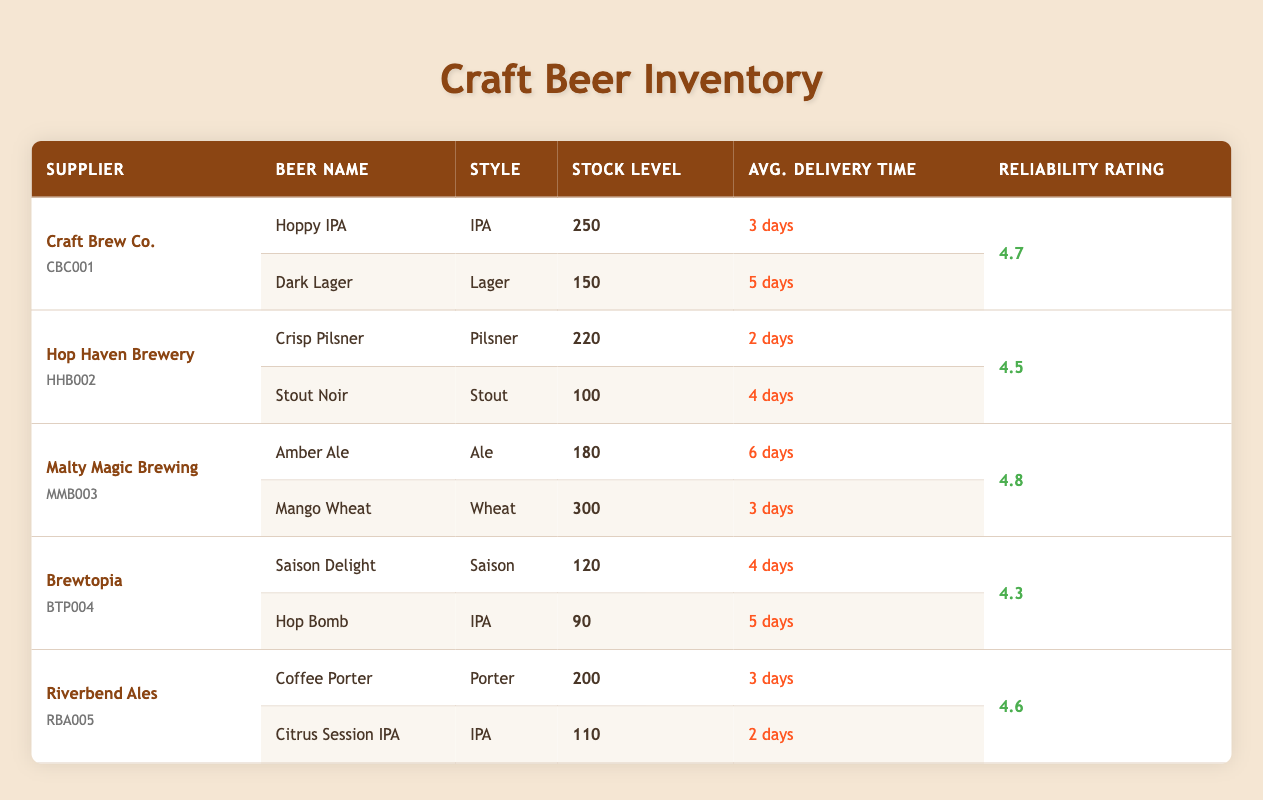What is the stock level for the Hoppy IPA? The Hoppy IPA is listed under Craft Brew Co., and its stock level is explicitly stated as 250 units in the table.
Answer: 250 Which supplier has the highest reliability rating? By checking the reliability ratings, Malty Magic Brewing has the highest rating of 4.8 compared to others, which are lower.
Answer: 4.8 What is the average delivery time for beers from Riverbend Ales? Riverbend Ales has two beers: Coffee Porter with an average delivery time of 3 days and Citrus Session IPA with 2 days. The average is (3 + 2)/2 = 2.5 days.
Answer: 2.5 days How many beers from Hop Haven Brewery exceed a delivery time of 3 days? Hop Haven Brewery's product range shows Crisp Pilsner with 2 days and Stout Noir with 4 days. Only Stout Noir exceeds 3 days, so there is 1 beer.
Answer: 1 Does Brewtopia have any beers with a stock level higher than 130? Brewtopia's Saison Delight has a stock level of 120, and Hop Bomb has a stock level of 90. Both are lower than 130, so the answer is no.
Answer: No What is the total stock level of all beers supplied by Malty Magic Brewing? Malty Magic Brewing has Amber Ale with a stock level of 180 and Mango Wheat with 300. The total stock level is 180 + 300 = 480.
Answer: 480 Which beer has the shortest average delivery time and its corresponding supplier? The shortest delivery time in the table is 2 days for the Crisp Pilsner from Hop Haven Brewery.
Answer: Crisp Pilsner from Hop Haven Brewery Are there any beers from suppliers with a reliability rating below 4.5? Brewtopia has a reliability rating of 4.3, which is below 4.5, indicating yes, they do have beers that meet this criterion.
Answer: Yes What is the difference in stock level between Mango Wheat and Citrus Session IPA? Mango Wheat has a stock level of 300, and Citrus Session IPA has 110. The difference is 300 - 110 = 190.
Answer: 190 